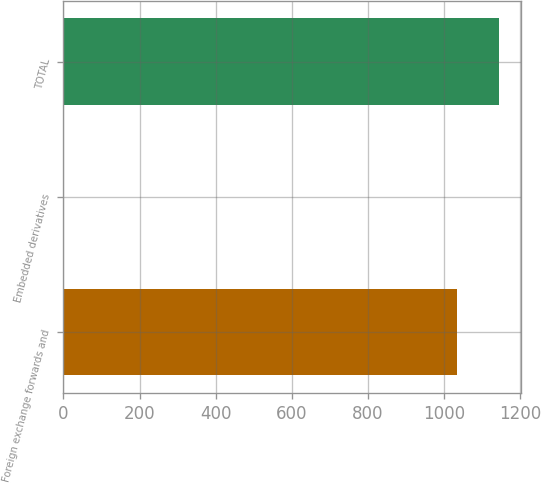Convert chart to OTSL. <chart><loc_0><loc_0><loc_500><loc_500><bar_chart><fcel>Foreign exchange forwards and<fcel>Embedded derivatives<fcel>TOTAL<nl><fcel>1034<fcel>2<fcel>1145.2<nl></chart> 